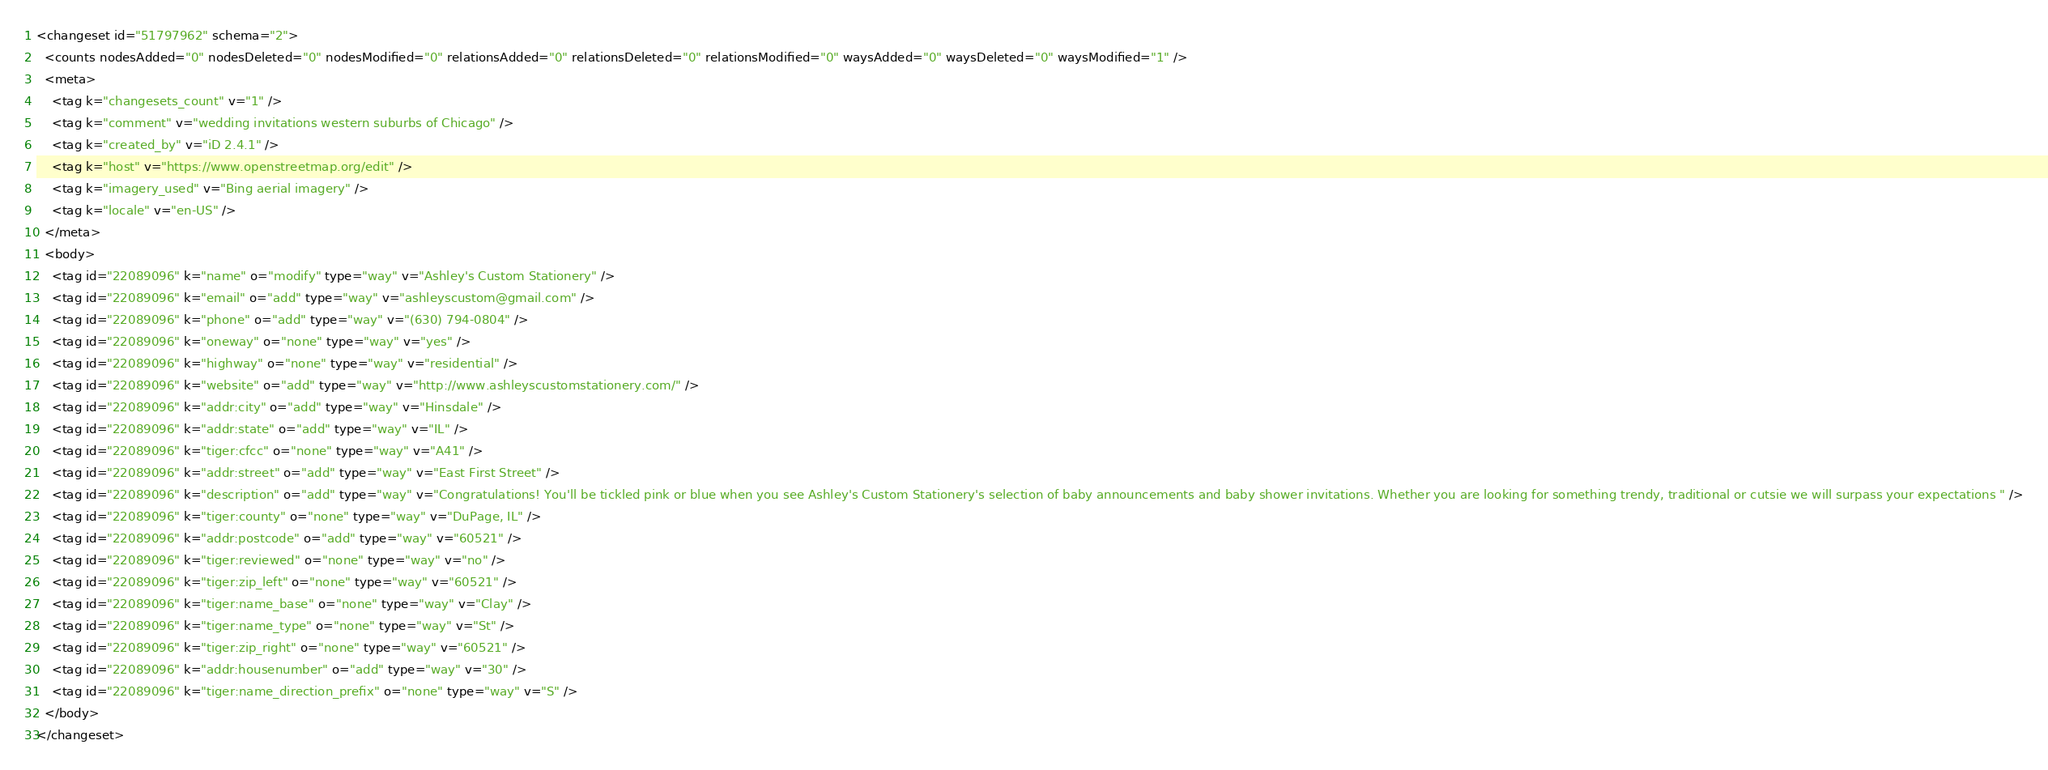Convert code to text. <code><loc_0><loc_0><loc_500><loc_500><_XML_><changeset id="51797962" schema="2">
  <counts nodesAdded="0" nodesDeleted="0" nodesModified="0" relationsAdded="0" relationsDeleted="0" relationsModified="0" waysAdded="0" waysDeleted="0" waysModified="1" />
  <meta>
    <tag k="changesets_count" v="1" />
    <tag k="comment" v="wedding invitations western suburbs of Chicago" />
    <tag k="created_by" v="iD 2.4.1" />
    <tag k="host" v="https://www.openstreetmap.org/edit" />
    <tag k="imagery_used" v="Bing aerial imagery" />
    <tag k="locale" v="en-US" />
  </meta>
  <body>
    <tag id="22089096" k="name" o="modify" type="way" v="Ashley's Custom Stationery" />
    <tag id="22089096" k="email" o="add" type="way" v="ashleyscustom@gmail.com" />
    <tag id="22089096" k="phone" o="add" type="way" v="(630) 794-0804" />
    <tag id="22089096" k="oneway" o="none" type="way" v="yes" />
    <tag id="22089096" k="highway" o="none" type="way" v="residential" />
    <tag id="22089096" k="website" o="add" type="way" v="http://www.ashleyscustomstationery.com/" />
    <tag id="22089096" k="addr:city" o="add" type="way" v="Hinsdale" />
    <tag id="22089096" k="addr:state" o="add" type="way" v="IL" />
    <tag id="22089096" k="tiger:cfcc" o="none" type="way" v="A41" />
    <tag id="22089096" k="addr:street" o="add" type="way" v="East First Street" />
    <tag id="22089096" k="description" o="add" type="way" v="Congratulations! You'll be tickled pink or blue when you see Ashley's Custom Stationery's selection of baby announcements and baby shower invitations. Whether you are looking for something trendy, traditional or cutsie we will surpass your expectations " />
    <tag id="22089096" k="tiger:county" o="none" type="way" v="DuPage, IL" />
    <tag id="22089096" k="addr:postcode" o="add" type="way" v="60521" />
    <tag id="22089096" k="tiger:reviewed" o="none" type="way" v="no" />
    <tag id="22089096" k="tiger:zip_left" o="none" type="way" v="60521" />
    <tag id="22089096" k="tiger:name_base" o="none" type="way" v="Clay" />
    <tag id="22089096" k="tiger:name_type" o="none" type="way" v="St" />
    <tag id="22089096" k="tiger:zip_right" o="none" type="way" v="60521" />
    <tag id="22089096" k="addr:housenumber" o="add" type="way" v="30" />
    <tag id="22089096" k="tiger:name_direction_prefix" o="none" type="way" v="S" />
  </body>
</changeset>
</code> 